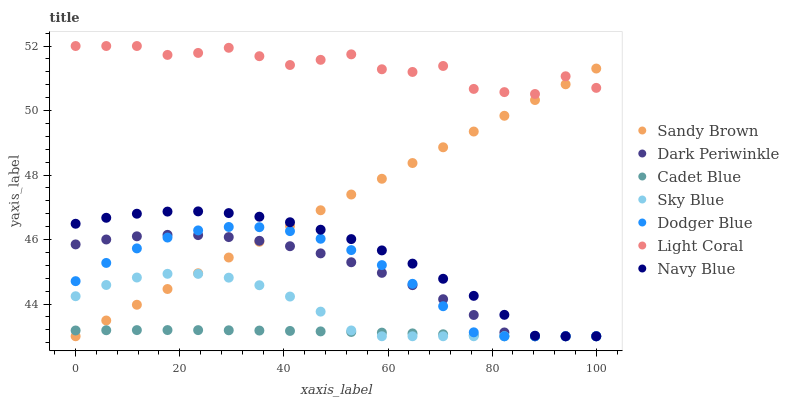Does Cadet Blue have the minimum area under the curve?
Answer yes or no. Yes. Does Light Coral have the maximum area under the curve?
Answer yes or no. Yes. Does Navy Blue have the minimum area under the curve?
Answer yes or no. No. Does Navy Blue have the maximum area under the curve?
Answer yes or no. No. Is Sandy Brown the smoothest?
Answer yes or no. Yes. Is Light Coral the roughest?
Answer yes or no. Yes. Is Navy Blue the smoothest?
Answer yes or no. No. Is Navy Blue the roughest?
Answer yes or no. No. Does Cadet Blue have the lowest value?
Answer yes or no. Yes. Does Light Coral have the lowest value?
Answer yes or no. No. Does Light Coral have the highest value?
Answer yes or no. Yes. Does Navy Blue have the highest value?
Answer yes or no. No. Is Navy Blue less than Light Coral?
Answer yes or no. Yes. Is Light Coral greater than Dodger Blue?
Answer yes or no. Yes. Does Navy Blue intersect Dark Periwinkle?
Answer yes or no. Yes. Is Navy Blue less than Dark Periwinkle?
Answer yes or no. No. Is Navy Blue greater than Dark Periwinkle?
Answer yes or no. No. Does Navy Blue intersect Light Coral?
Answer yes or no. No. 